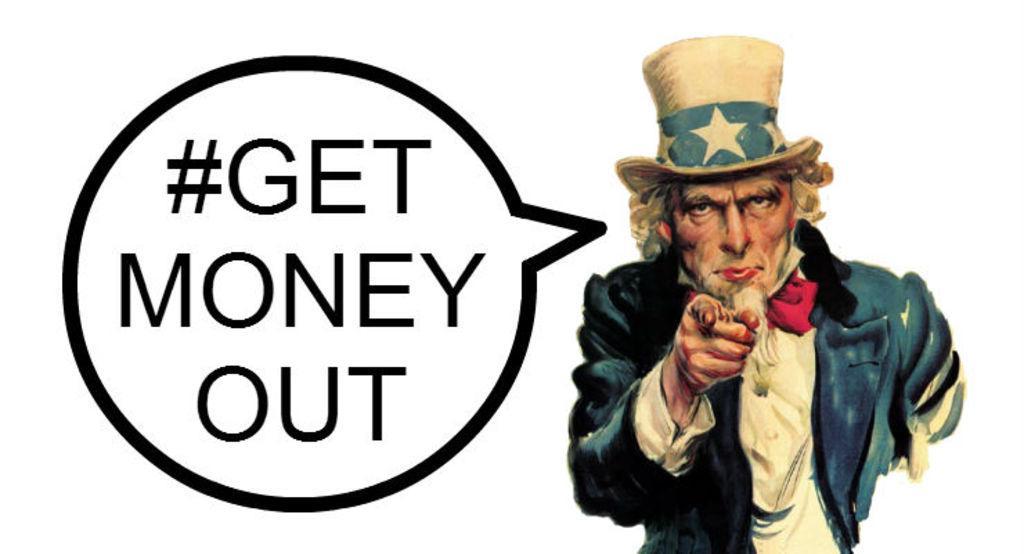How would you summarize this image in a sentence or two? On the right side of the image we can see person. On the left side of the image there is text. 